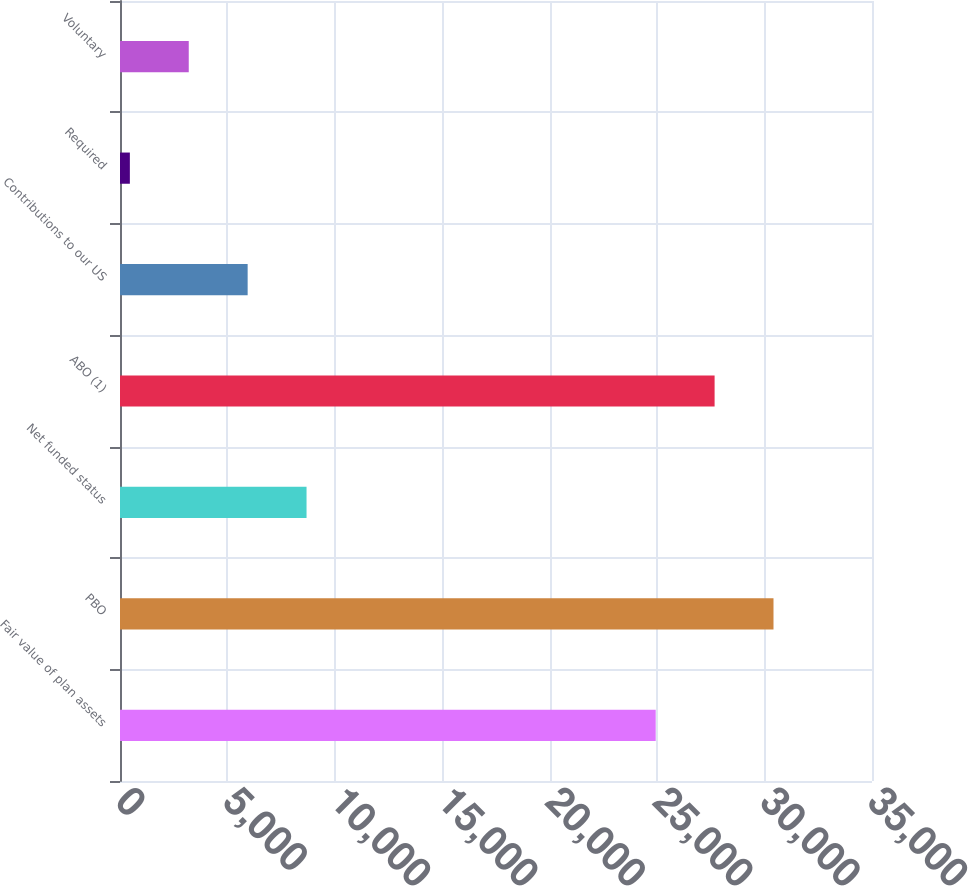Convert chart to OTSL. <chart><loc_0><loc_0><loc_500><loc_500><bar_chart><fcel>Fair value of plan assets<fcel>PBO<fcel>Net funded status<fcel>ABO (1)<fcel>Contributions to our US<fcel>Required<fcel>Voluntary<nl><fcel>24933<fcel>30415.2<fcel>8682.3<fcel>27674.1<fcel>5941.2<fcel>459<fcel>3200.1<nl></chart> 